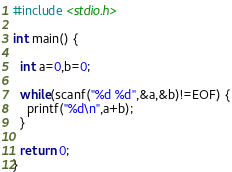Convert code to text. <code><loc_0><loc_0><loc_500><loc_500><_C_>#include <stdio.h>

int main() {

  int a=0,b=0;

  while(scanf("%d %d",&a,&b)!=EOF) {
    printf("%d\n",a+b);
  }

  return 0;
}</code> 